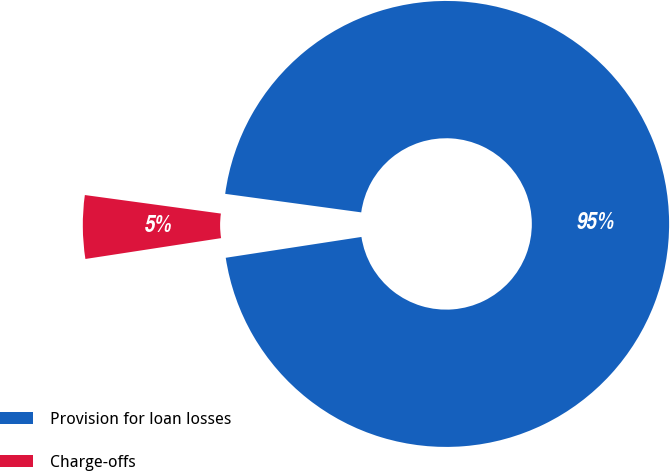Convert chart. <chart><loc_0><loc_0><loc_500><loc_500><pie_chart><fcel>Provision for loan losses<fcel>Charge-offs<nl><fcel>95.42%<fcel>4.58%<nl></chart> 